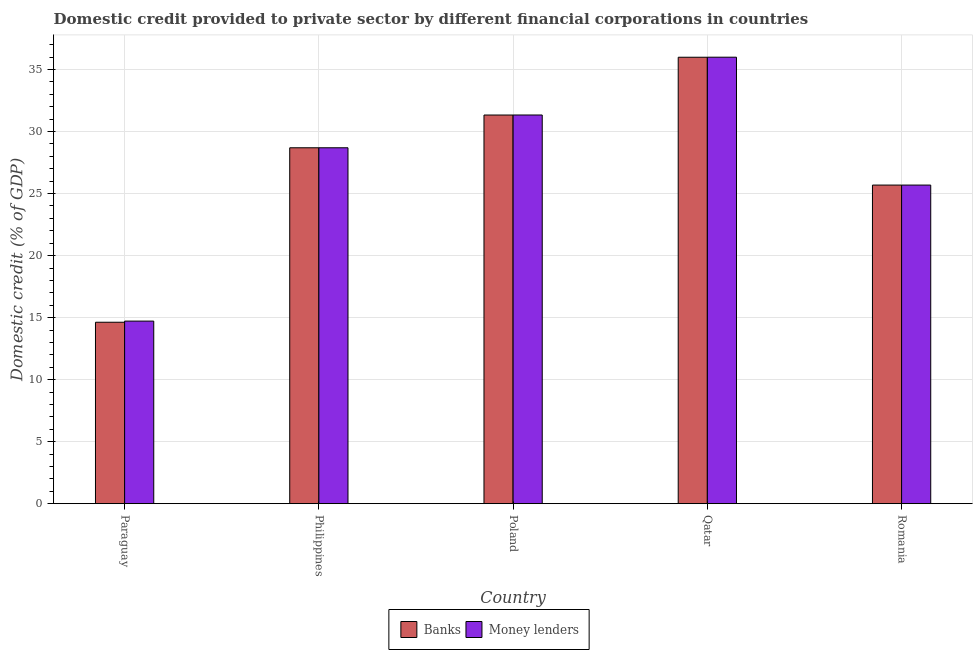How many different coloured bars are there?
Offer a terse response. 2. Are the number of bars per tick equal to the number of legend labels?
Provide a short and direct response. Yes. Are the number of bars on each tick of the X-axis equal?
Offer a terse response. Yes. How many bars are there on the 5th tick from the left?
Your answer should be compact. 2. What is the domestic credit provided by money lenders in Romania?
Offer a very short reply. 25.69. Across all countries, what is the maximum domestic credit provided by banks?
Provide a short and direct response. 35.99. Across all countries, what is the minimum domestic credit provided by money lenders?
Offer a terse response. 14.72. In which country was the domestic credit provided by banks maximum?
Ensure brevity in your answer.  Qatar. In which country was the domestic credit provided by money lenders minimum?
Your response must be concise. Paraguay. What is the total domestic credit provided by banks in the graph?
Keep it short and to the point. 136.34. What is the difference between the domestic credit provided by money lenders in Paraguay and that in Romania?
Give a very brief answer. -10.97. What is the difference between the domestic credit provided by banks in Qatar and the domestic credit provided by money lenders in Romania?
Your answer should be very brief. 10.31. What is the average domestic credit provided by banks per country?
Give a very brief answer. 27.27. What is the difference between the domestic credit provided by banks and domestic credit provided by money lenders in Romania?
Offer a very short reply. 0. What is the ratio of the domestic credit provided by money lenders in Paraguay to that in Romania?
Ensure brevity in your answer.  0.57. Is the domestic credit provided by banks in Philippines less than that in Qatar?
Offer a very short reply. Yes. Is the difference between the domestic credit provided by money lenders in Paraguay and Poland greater than the difference between the domestic credit provided by banks in Paraguay and Poland?
Make the answer very short. Yes. What is the difference between the highest and the second highest domestic credit provided by money lenders?
Offer a terse response. 4.66. What is the difference between the highest and the lowest domestic credit provided by banks?
Keep it short and to the point. 21.37. In how many countries, is the domestic credit provided by banks greater than the average domestic credit provided by banks taken over all countries?
Your answer should be very brief. 3. Is the sum of the domestic credit provided by banks in Paraguay and Philippines greater than the maximum domestic credit provided by money lenders across all countries?
Offer a very short reply. Yes. What does the 2nd bar from the left in Philippines represents?
Make the answer very short. Money lenders. What does the 1st bar from the right in Romania represents?
Your answer should be very brief. Money lenders. How many bars are there?
Offer a terse response. 10. Are the values on the major ticks of Y-axis written in scientific E-notation?
Your answer should be compact. No. Does the graph contain any zero values?
Offer a very short reply. No. Where does the legend appear in the graph?
Your answer should be compact. Bottom center. How many legend labels are there?
Offer a terse response. 2. How are the legend labels stacked?
Ensure brevity in your answer.  Horizontal. What is the title of the graph?
Ensure brevity in your answer.  Domestic credit provided to private sector by different financial corporations in countries. What is the label or title of the Y-axis?
Ensure brevity in your answer.  Domestic credit (% of GDP). What is the Domestic credit (% of GDP) of Banks in Paraguay?
Your answer should be compact. 14.63. What is the Domestic credit (% of GDP) of Money lenders in Paraguay?
Offer a very short reply. 14.72. What is the Domestic credit (% of GDP) of Banks in Philippines?
Offer a terse response. 28.69. What is the Domestic credit (% of GDP) of Money lenders in Philippines?
Offer a terse response. 28.69. What is the Domestic credit (% of GDP) in Banks in Poland?
Give a very brief answer. 31.33. What is the Domestic credit (% of GDP) of Money lenders in Poland?
Your answer should be compact. 31.34. What is the Domestic credit (% of GDP) of Banks in Qatar?
Provide a succinct answer. 35.99. What is the Domestic credit (% of GDP) in Money lenders in Qatar?
Give a very brief answer. 36. What is the Domestic credit (% of GDP) of Banks in Romania?
Offer a terse response. 25.69. What is the Domestic credit (% of GDP) of Money lenders in Romania?
Ensure brevity in your answer.  25.69. Across all countries, what is the maximum Domestic credit (% of GDP) in Banks?
Provide a succinct answer. 35.99. Across all countries, what is the maximum Domestic credit (% of GDP) of Money lenders?
Provide a short and direct response. 36. Across all countries, what is the minimum Domestic credit (% of GDP) in Banks?
Your answer should be very brief. 14.63. Across all countries, what is the minimum Domestic credit (% of GDP) in Money lenders?
Provide a short and direct response. 14.72. What is the total Domestic credit (% of GDP) of Banks in the graph?
Offer a very short reply. 136.34. What is the total Domestic credit (% of GDP) of Money lenders in the graph?
Give a very brief answer. 136.44. What is the difference between the Domestic credit (% of GDP) of Banks in Paraguay and that in Philippines?
Give a very brief answer. -14.07. What is the difference between the Domestic credit (% of GDP) of Money lenders in Paraguay and that in Philippines?
Offer a very short reply. -13.98. What is the difference between the Domestic credit (% of GDP) of Banks in Paraguay and that in Poland?
Offer a terse response. -16.71. What is the difference between the Domestic credit (% of GDP) of Money lenders in Paraguay and that in Poland?
Provide a succinct answer. -16.62. What is the difference between the Domestic credit (% of GDP) in Banks in Paraguay and that in Qatar?
Ensure brevity in your answer.  -21.37. What is the difference between the Domestic credit (% of GDP) of Money lenders in Paraguay and that in Qatar?
Ensure brevity in your answer.  -21.28. What is the difference between the Domestic credit (% of GDP) in Banks in Paraguay and that in Romania?
Ensure brevity in your answer.  -11.06. What is the difference between the Domestic credit (% of GDP) of Money lenders in Paraguay and that in Romania?
Provide a short and direct response. -10.97. What is the difference between the Domestic credit (% of GDP) of Banks in Philippines and that in Poland?
Your response must be concise. -2.64. What is the difference between the Domestic credit (% of GDP) in Money lenders in Philippines and that in Poland?
Offer a terse response. -2.64. What is the difference between the Domestic credit (% of GDP) of Banks in Philippines and that in Qatar?
Offer a terse response. -7.3. What is the difference between the Domestic credit (% of GDP) of Money lenders in Philippines and that in Qatar?
Ensure brevity in your answer.  -7.3. What is the difference between the Domestic credit (% of GDP) of Banks in Philippines and that in Romania?
Your response must be concise. 3.01. What is the difference between the Domestic credit (% of GDP) in Money lenders in Philippines and that in Romania?
Give a very brief answer. 3.01. What is the difference between the Domestic credit (% of GDP) in Banks in Poland and that in Qatar?
Your answer should be very brief. -4.66. What is the difference between the Domestic credit (% of GDP) of Money lenders in Poland and that in Qatar?
Provide a succinct answer. -4.66. What is the difference between the Domestic credit (% of GDP) in Banks in Poland and that in Romania?
Your answer should be compact. 5.65. What is the difference between the Domestic credit (% of GDP) of Money lenders in Poland and that in Romania?
Your answer should be very brief. 5.65. What is the difference between the Domestic credit (% of GDP) in Banks in Qatar and that in Romania?
Provide a succinct answer. 10.31. What is the difference between the Domestic credit (% of GDP) in Money lenders in Qatar and that in Romania?
Keep it short and to the point. 10.31. What is the difference between the Domestic credit (% of GDP) of Banks in Paraguay and the Domestic credit (% of GDP) of Money lenders in Philippines?
Ensure brevity in your answer.  -14.07. What is the difference between the Domestic credit (% of GDP) in Banks in Paraguay and the Domestic credit (% of GDP) in Money lenders in Poland?
Keep it short and to the point. -16.71. What is the difference between the Domestic credit (% of GDP) of Banks in Paraguay and the Domestic credit (% of GDP) of Money lenders in Qatar?
Provide a short and direct response. -21.37. What is the difference between the Domestic credit (% of GDP) in Banks in Paraguay and the Domestic credit (% of GDP) in Money lenders in Romania?
Offer a terse response. -11.06. What is the difference between the Domestic credit (% of GDP) of Banks in Philippines and the Domestic credit (% of GDP) of Money lenders in Poland?
Offer a terse response. -2.64. What is the difference between the Domestic credit (% of GDP) in Banks in Philippines and the Domestic credit (% of GDP) in Money lenders in Qatar?
Provide a succinct answer. -7.3. What is the difference between the Domestic credit (% of GDP) of Banks in Philippines and the Domestic credit (% of GDP) of Money lenders in Romania?
Your answer should be compact. 3.01. What is the difference between the Domestic credit (% of GDP) in Banks in Poland and the Domestic credit (% of GDP) in Money lenders in Qatar?
Offer a terse response. -4.66. What is the difference between the Domestic credit (% of GDP) in Banks in Poland and the Domestic credit (% of GDP) in Money lenders in Romania?
Ensure brevity in your answer.  5.65. What is the difference between the Domestic credit (% of GDP) of Banks in Qatar and the Domestic credit (% of GDP) of Money lenders in Romania?
Your answer should be compact. 10.31. What is the average Domestic credit (% of GDP) of Banks per country?
Your response must be concise. 27.27. What is the average Domestic credit (% of GDP) of Money lenders per country?
Offer a terse response. 27.29. What is the difference between the Domestic credit (% of GDP) of Banks and Domestic credit (% of GDP) of Money lenders in Paraguay?
Provide a succinct answer. -0.09. What is the difference between the Domestic credit (% of GDP) in Banks and Domestic credit (% of GDP) in Money lenders in Philippines?
Provide a short and direct response. -0. What is the difference between the Domestic credit (% of GDP) in Banks and Domestic credit (% of GDP) in Money lenders in Poland?
Provide a short and direct response. -0. What is the difference between the Domestic credit (% of GDP) in Banks and Domestic credit (% of GDP) in Money lenders in Qatar?
Keep it short and to the point. -0. What is the ratio of the Domestic credit (% of GDP) in Banks in Paraguay to that in Philippines?
Make the answer very short. 0.51. What is the ratio of the Domestic credit (% of GDP) of Money lenders in Paraguay to that in Philippines?
Ensure brevity in your answer.  0.51. What is the ratio of the Domestic credit (% of GDP) of Banks in Paraguay to that in Poland?
Offer a very short reply. 0.47. What is the ratio of the Domestic credit (% of GDP) of Money lenders in Paraguay to that in Poland?
Your answer should be very brief. 0.47. What is the ratio of the Domestic credit (% of GDP) in Banks in Paraguay to that in Qatar?
Provide a short and direct response. 0.41. What is the ratio of the Domestic credit (% of GDP) of Money lenders in Paraguay to that in Qatar?
Your answer should be compact. 0.41. What is the ratio of the Domestic credit (% of GDP) of Banks in Paraguay to that in Romania?
Provide a succinct answer. 0.57. What is the ratio of the Domestic credit (% of GDP) in Money lenders in Paraguay to that in Romania?
Give a very brief answer. 0.57. What is the ratio of the Domestic credit (% of GDP) of Banks in Philippines to that in Poland?
Make the answer very short. 0.92. What is the ratio of the Domestic credit (% of GDP) of Money lenders in Philippines to that in Poland?
Keep it short and to the point. 0.92. What is the ratio of the Domestic credit (% of GDP) of Banks in Philippines to that in Qatar?
Ensure brevity in your answer.  0.8. What is the ratio of the Domestic credit (% of GDP) of Money lenders in Philippines to that in Qatar?
Provide a short and direct response. 0.8. What is the ratio of the Domestic credit (% of GDP) in Banks in Philippines to that in Romania?
Offer a terse response. 1.12. What is the ratio of the Domestic credit (% of GDP) in Money lenders in Philippines to that in Romania?
Keep it short and to the point. 1.12. What is the ratio of the Domestic credit (% of GDP) in Banks in Poland to that in Qatar?
Keep it short and to the point. 0.87. What is the ratio of the Domestic credit (% of GDP) in Money lenders in Poland to that in Qatar?
Ensure brevity in your answer.  0.87. What is the ratio of the Domestic credit (% of GDP) of Banks in Poland to that in Romania?
Ensure brevity in your answer.  1.22. What is the ratio of the Domestic credit (% of GDP) of Money lenders in Poland to that in Romania?
Your answer should be compact. 1.22. What is the ratio of the Domestic credit (% of GDP) of Banks in Qatar to that in Romania?
Provide a succinct answer. 1.4. What is the ratio of the Domestic credit (% of GDP) of Money lenders in Qatar to that in Romania?
Provide a short and direct response. 1.4. What is the difference between the highest and the second highest Domestic credit (% of GDP) of Banks?
Provide a succinct answer. 4.66. What is the difference between the highest and the second highest Domestic credit (% of GDP) in Money lenders?
Offer a very short reply. 4.66. What is the difference between the highest and the lowest Domestic credit (% of GDP) of Banks?
Offer a terse response. 21.37. What is the difference between the highest and the lowest Domestic credit (% of GDP) in Money lenders?
Your answer should be very brief. 21.28. 